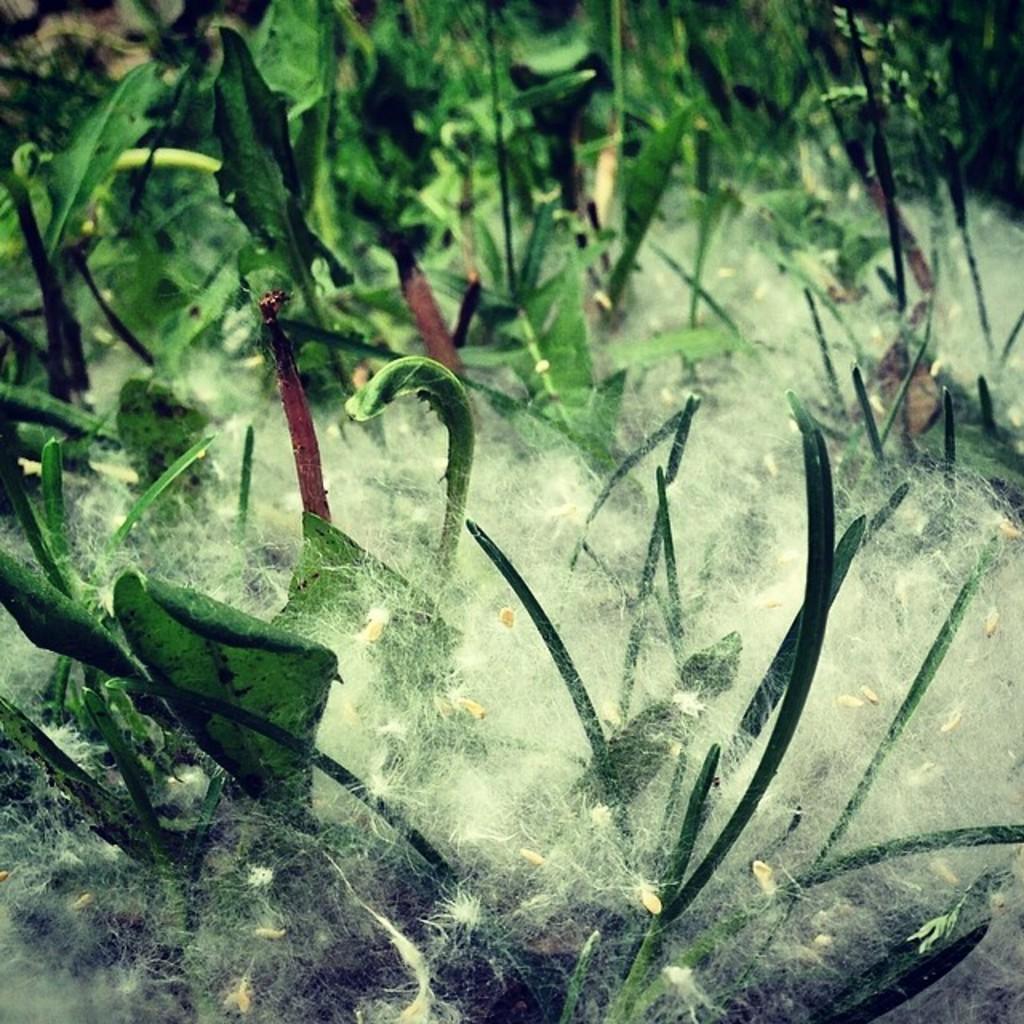Please provide a concise description of this image. In the foreground of this image, it seems like weed plants with some white cotton to it. 